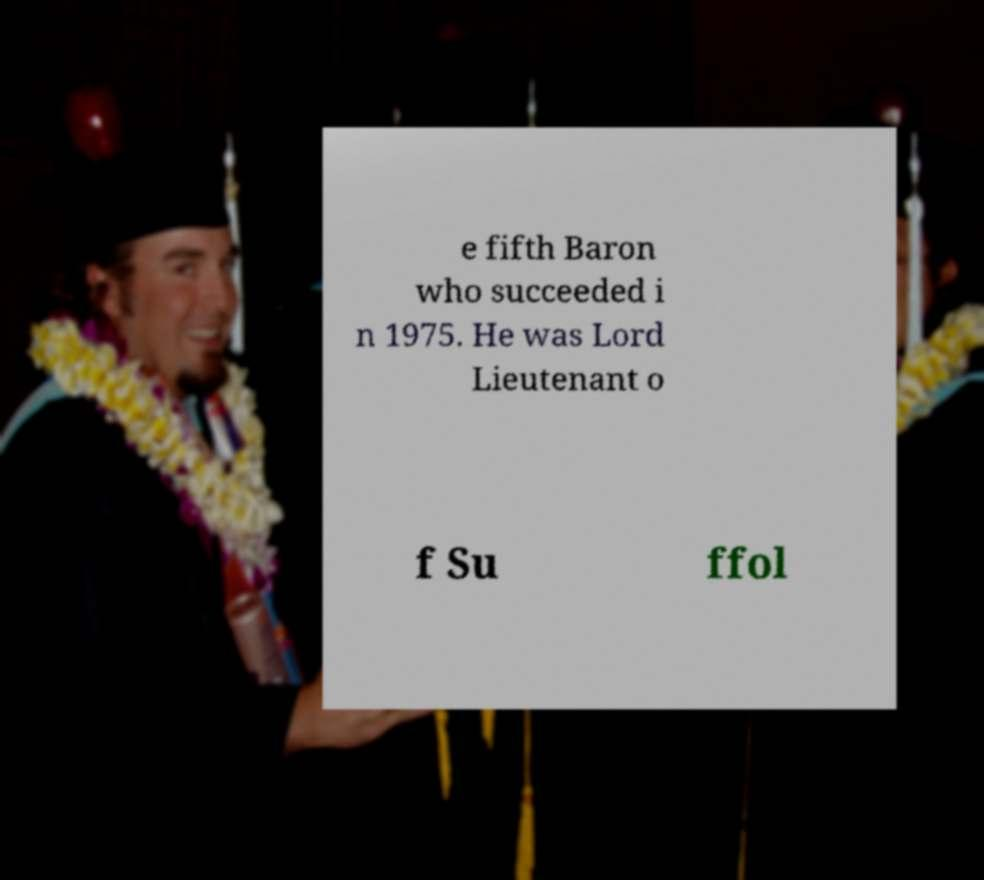Could you extract and type out the text from this image? e fifth Baron who succeeded i n 1975. He was Lord Lieutenant o f Su ffol 